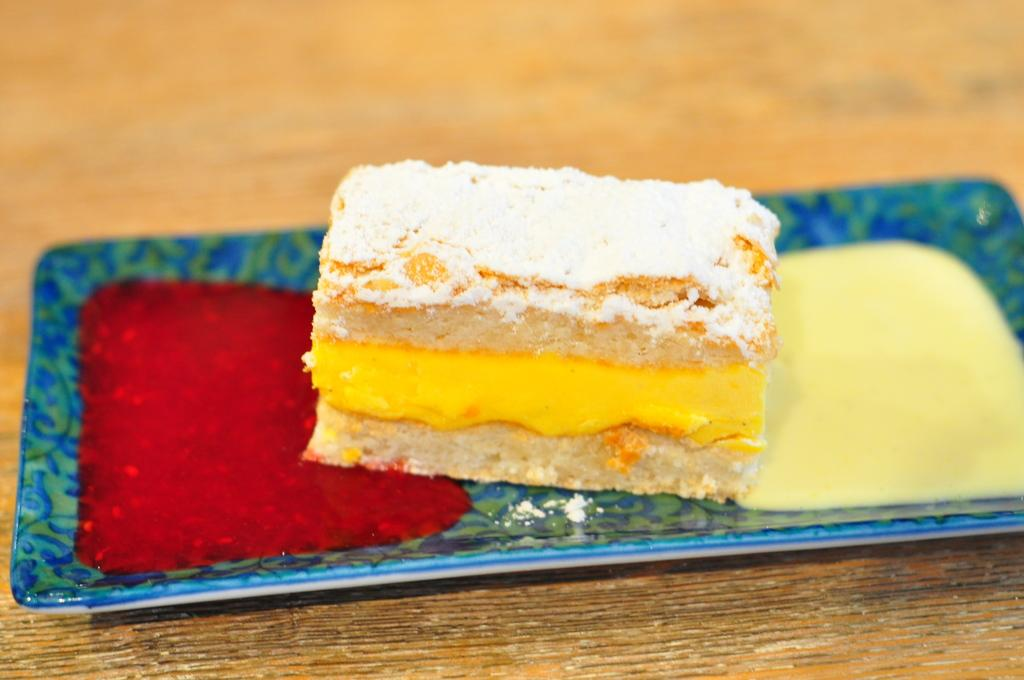What color is the tray in the image? The tray in the image is blue. What is on the tray? The tray contains a cake. Where is the tray located? The tray is placed on a table. Can you describe the background of the image? The background of the image is blurred. How does the fog affect the cake on the tray in the image? There is no fog present in the image; the background is blurred, but it is not specifically mentioned as fog. 